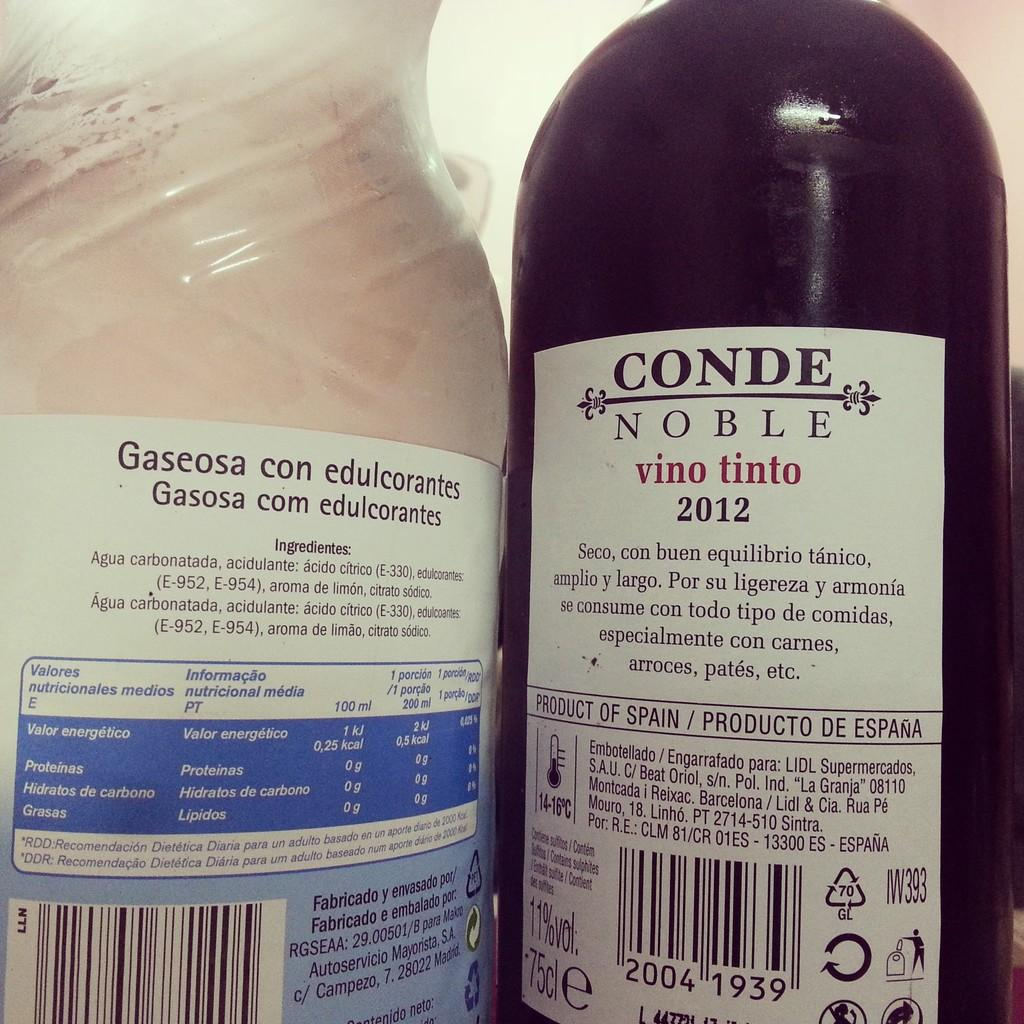<image>
Summarize the visual content of the image. The back label of a bottle of Conde Noble wine shows it is a product of Spain. 